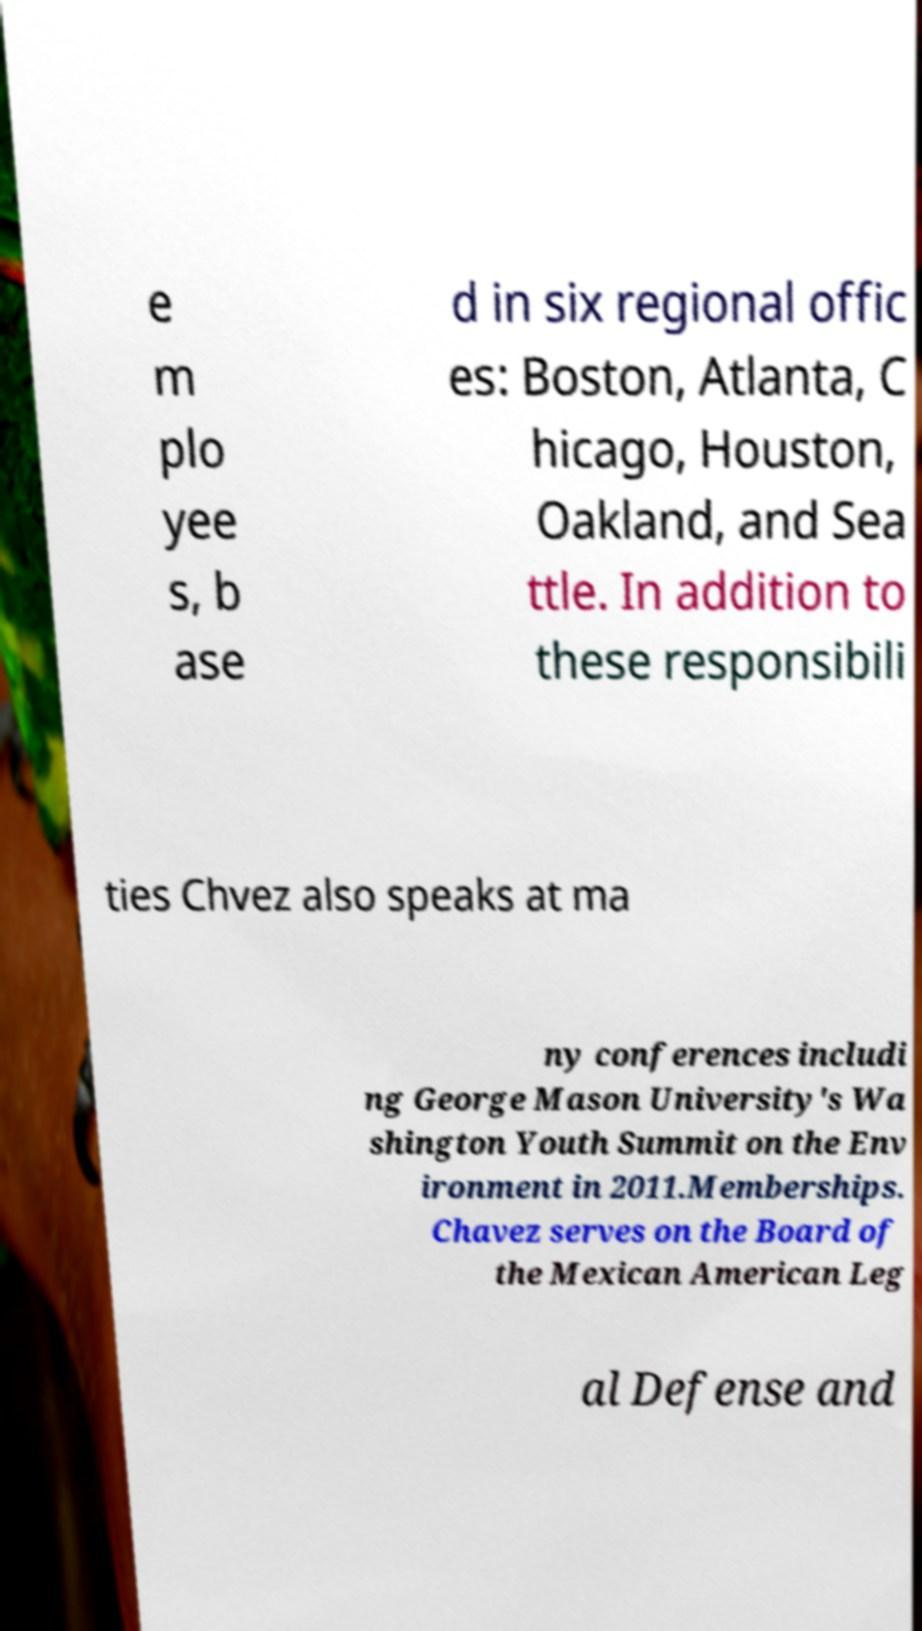Can you read and provide the text displayed in the image?This photo seems to have some interesting text. Can you extract and type it out for me? e m plo yee s, b ase d in six regional offic es: Boston, Atlanta, C hicago, Houston, Oakland, and Sea ttle. In addition to these responsibili ties Chvez also speaks at ma ny conferences includi ng George Mason University's Wa shington Youth Summit on the Env ironment in 2011.Memberships. Chavez serves on the Board of the Mexican American Leg al Defense and 